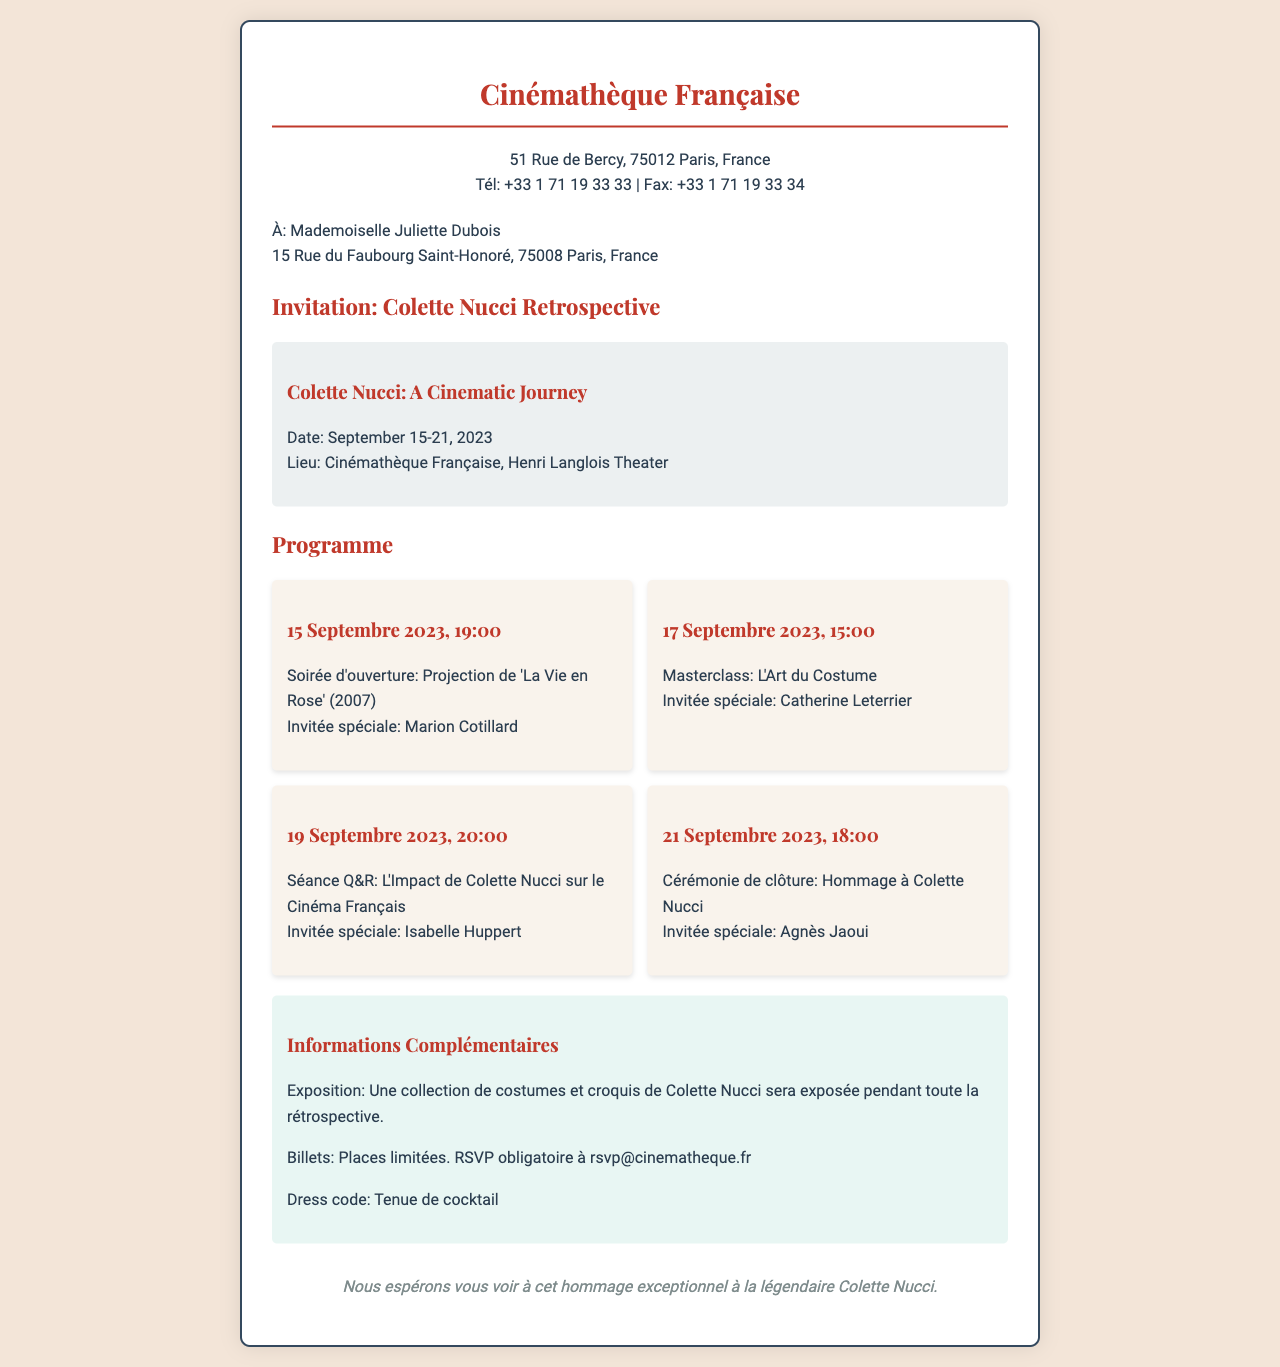Quel est le nom de la réalisatrice honorée ? Le nom de la réalisatrice honorée dans l'invitation est Colette Nucci.
Answer: Colette Nucci Quelle est la date de la soirée d'ouverture ? La soirée d'ouverture a lieu le 15 septembre 2023, comme indiqué dans le programme.
Answer: 15 Septembre 2023 Qui est l'invitée spéciale de la cérémonie de clôture ? L'invitée spéciale pour la cérémonie de clôture est Agnès Jaoui, mentionnée dans le programme.
Answer: Agnès Jaoui Où se déroule la rétrospective ? La rétrospective se déroule à la Cinémathèque Française, selon le document.
Answer: Cinémathèque Française Quel est le dress code de l'événement ? Le dress code spécifié dans le document est une tenue de cocktail.
Answer: Tenue de cocktail Combien de jours dure l'événement ? L'événement a lieu du 15 au 21 septembre, ce qui représente une durée de 7 jours.
Answer: 7 jours Quel type d'exposition est mentionné dans le document ? Le document mentionne une exposition de costumes et croquis de Colette Nucci.
Answer: Une collection de costumes et croquis À quelle adresse doit-on envoyer une confirmation de présence ? Le document précise que les confirmations doivent être envoyées à rsvp@cinematheque.fr.
Answer: rsvp@cinematheque.fr Quelle est la première film à être projeté lors de la rétrospective ? Le premier film projeté lors de la rétrospective est 'La Vie en Rose' (2007).
Answer: 'La Vie en Rose' (2007) 